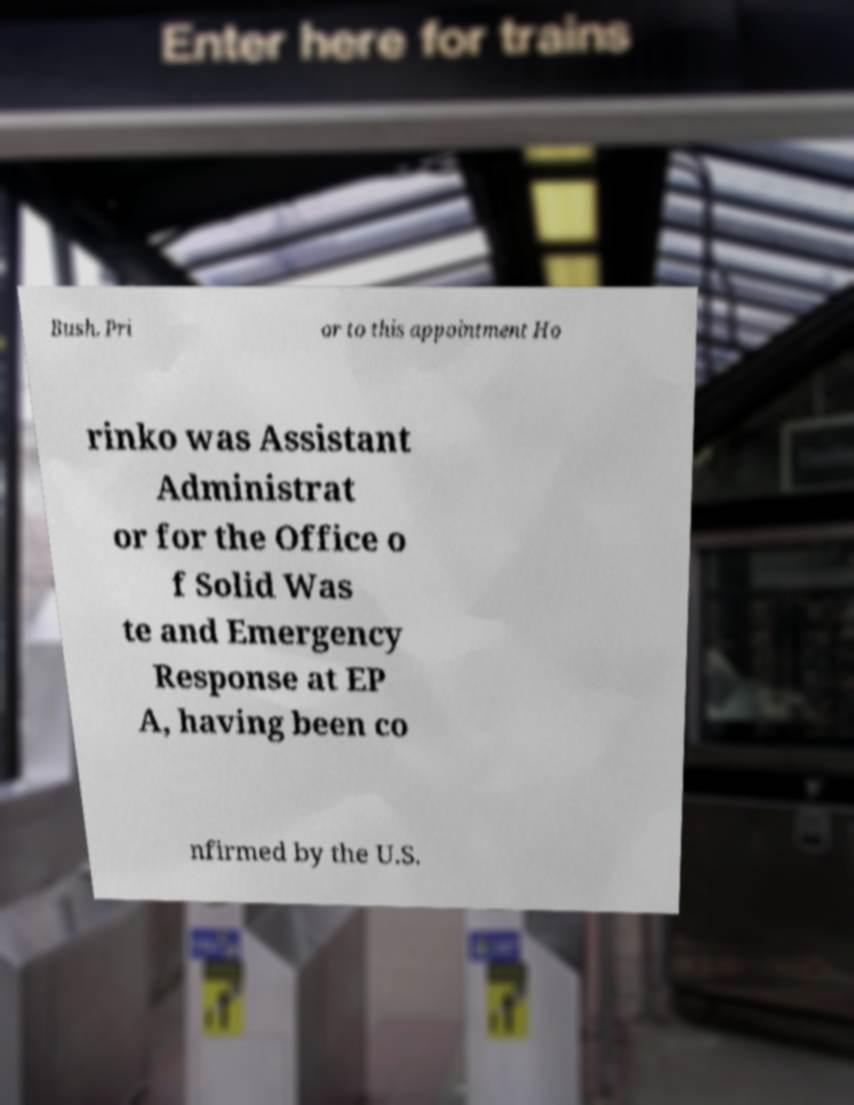I need the written content from this picture converted into text. Can you do that? Bush. Pri or to this appointment Ho rinko was Assistant Administrat or for the Office o f Solid Was te and Emergency Response at EP A, having been co nfirmed by the U.S. 